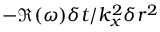Convert formula to latex. <formula><loc_0><loc_0><loc_500><loc_500>- \Re ( \omega ) \delta t / k _ { x } ^ { 2 } \delta r ^ { 2 }</formula> 